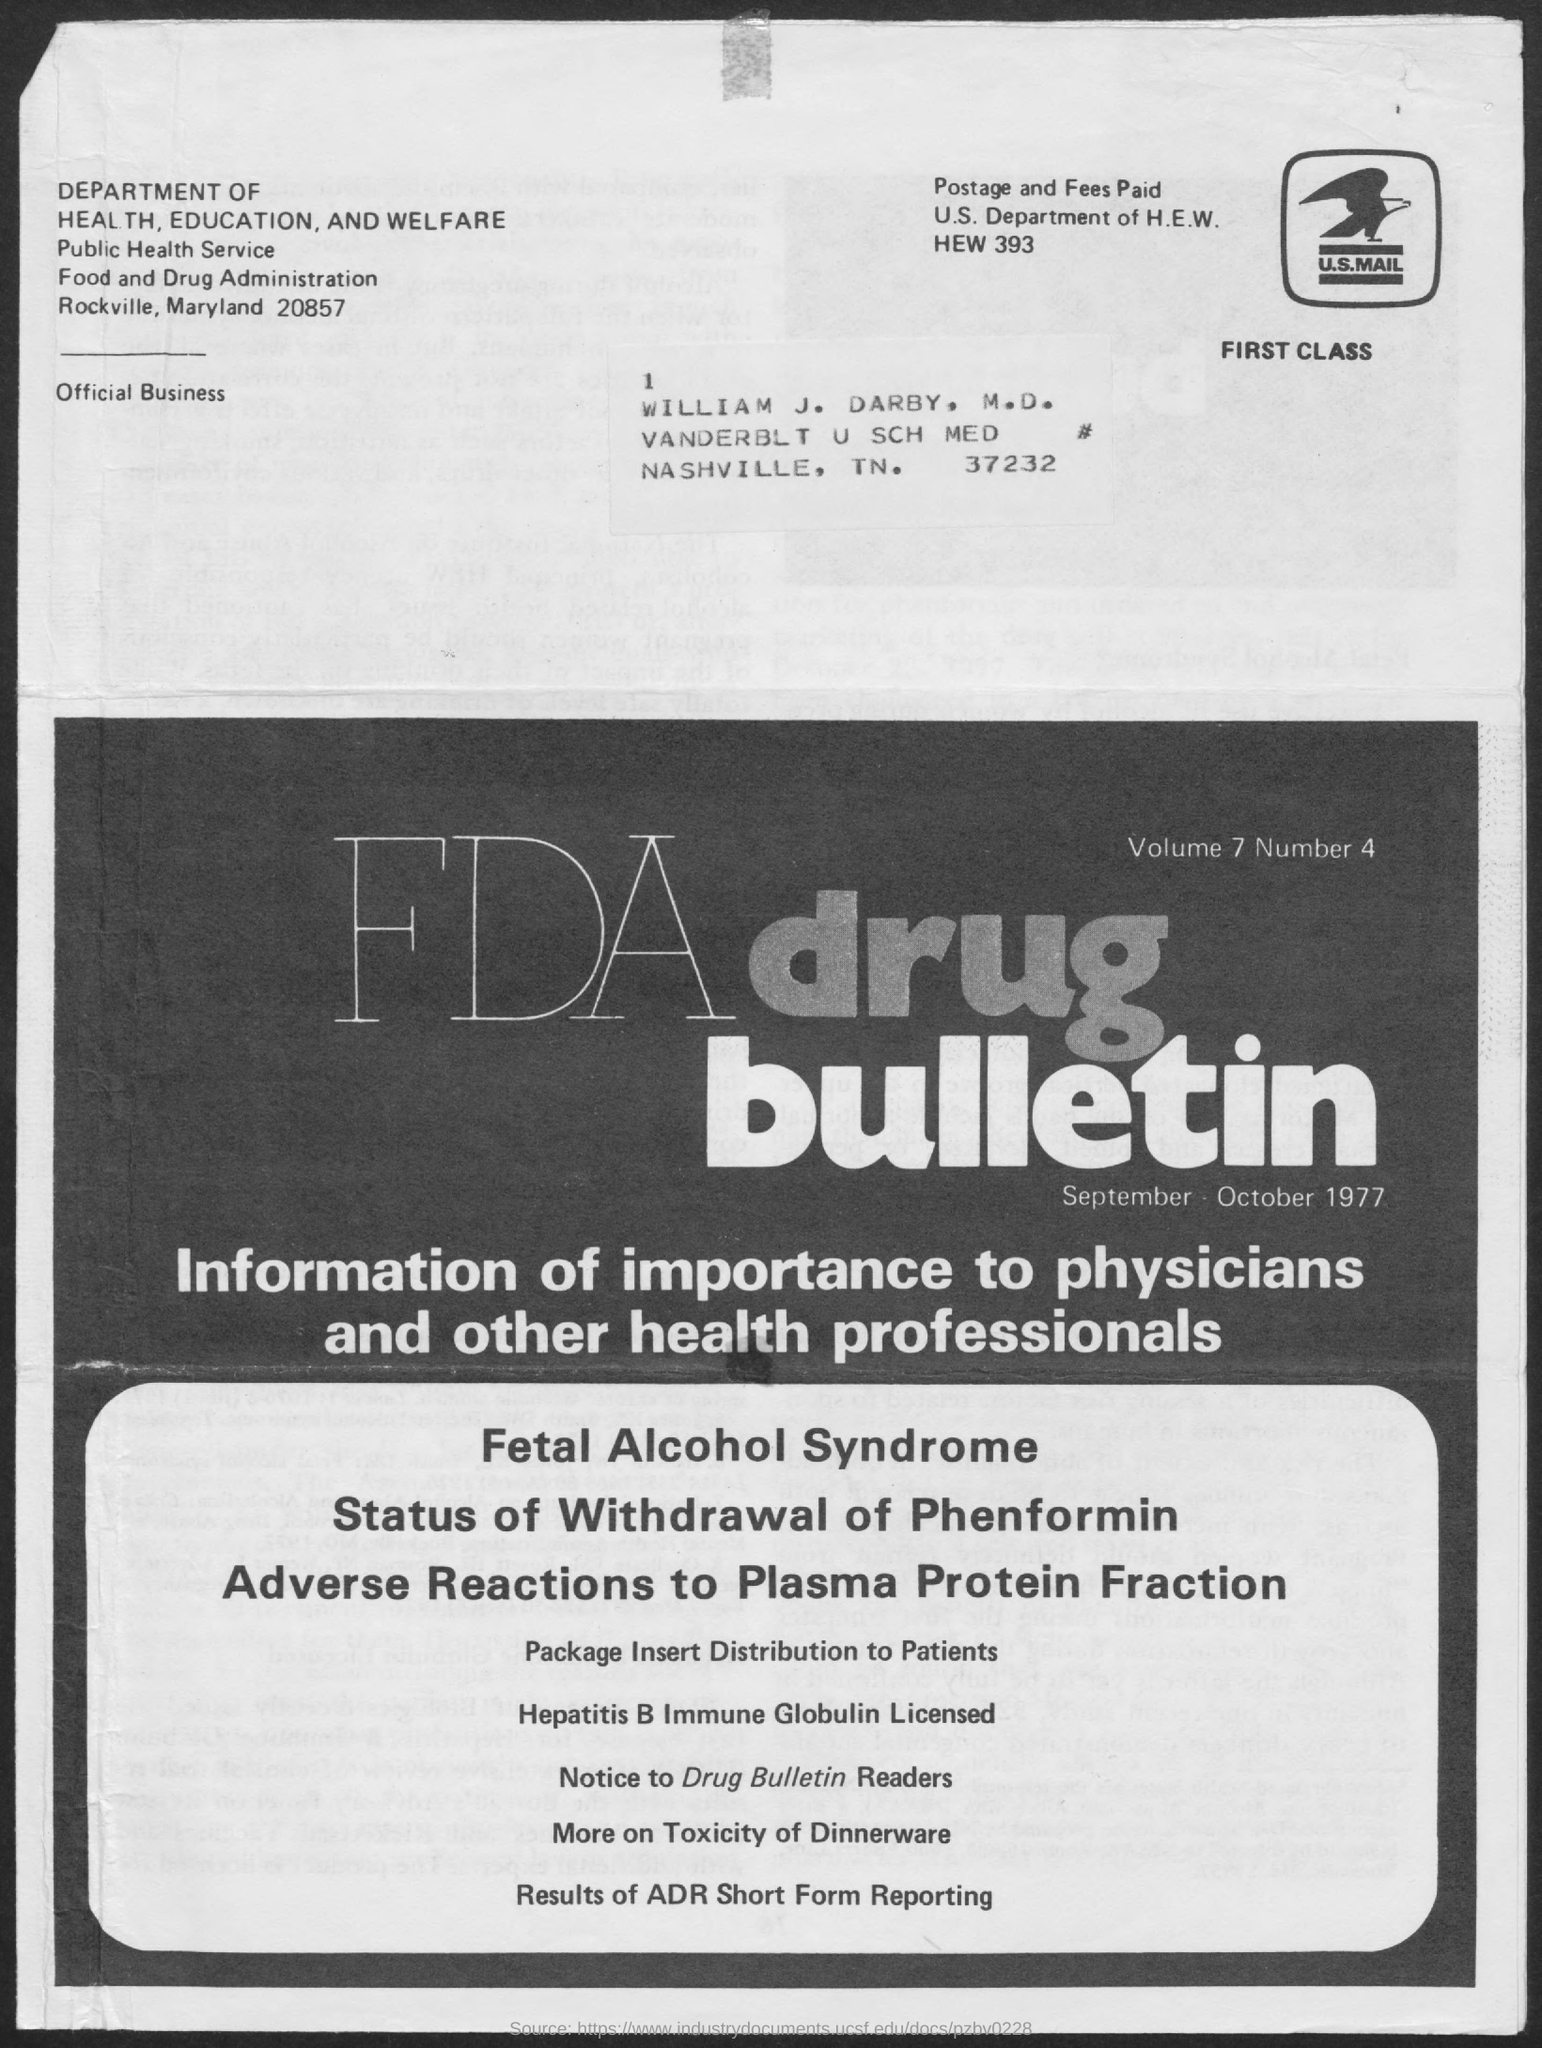To Whom is this  addressed to?
Provide a succinct answer. William J. Darby, M.D. What is the Volume?
Ensure brevity in your answer.  7. What is the Number?
Give a very brief answer. 4. Which months bulletin is this?
Your answer should be compact. SEPTEMBER-OCTOBER 1977. 